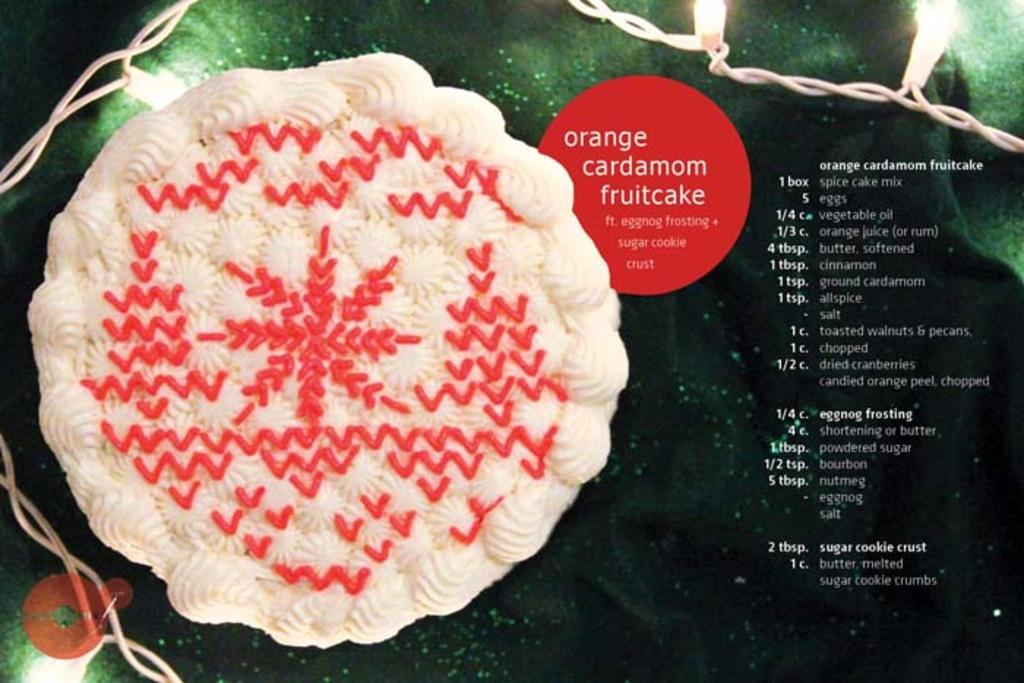What is the main subject of the image? There is a cake in the image. What else can be seen on the right side of the image? There is text on the right side of the image. Are there any additional elements in the top right corner of the image? Yes, there are lights in the top right corner of the image. Can you see a cow grazing on a twig in the image? No, there is no cow or twig present in the image. 